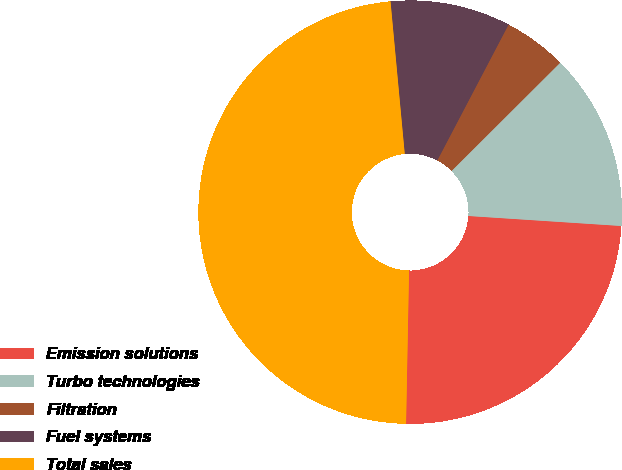Convert chart. <chart><loc_0><loc_0><loc_500><loc_500><pie_chart><fcel>Emission solutions<fcel>Turbo technologies<fcel>Filtration<fcel>Fuel systems<fcel>Total sales<nl><fcel>24.27%<fcel>13.51%<fcel>4.84%<fcel>9.17%<fcel>48.21%<nl></chart> 